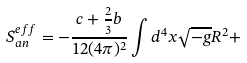Convert formula to latex. <formula><loc_0><loc_0><loc_500><loc_500>S ^ { e f f } _ { a n } = - \frac { c + \frac { 2 } { 3 } b } { 1 2 ( 4 \pi ) ^ { 2 } } \int d ^ { 4 } x \sqrt { - g } R ^ { 2 } +</formula> 